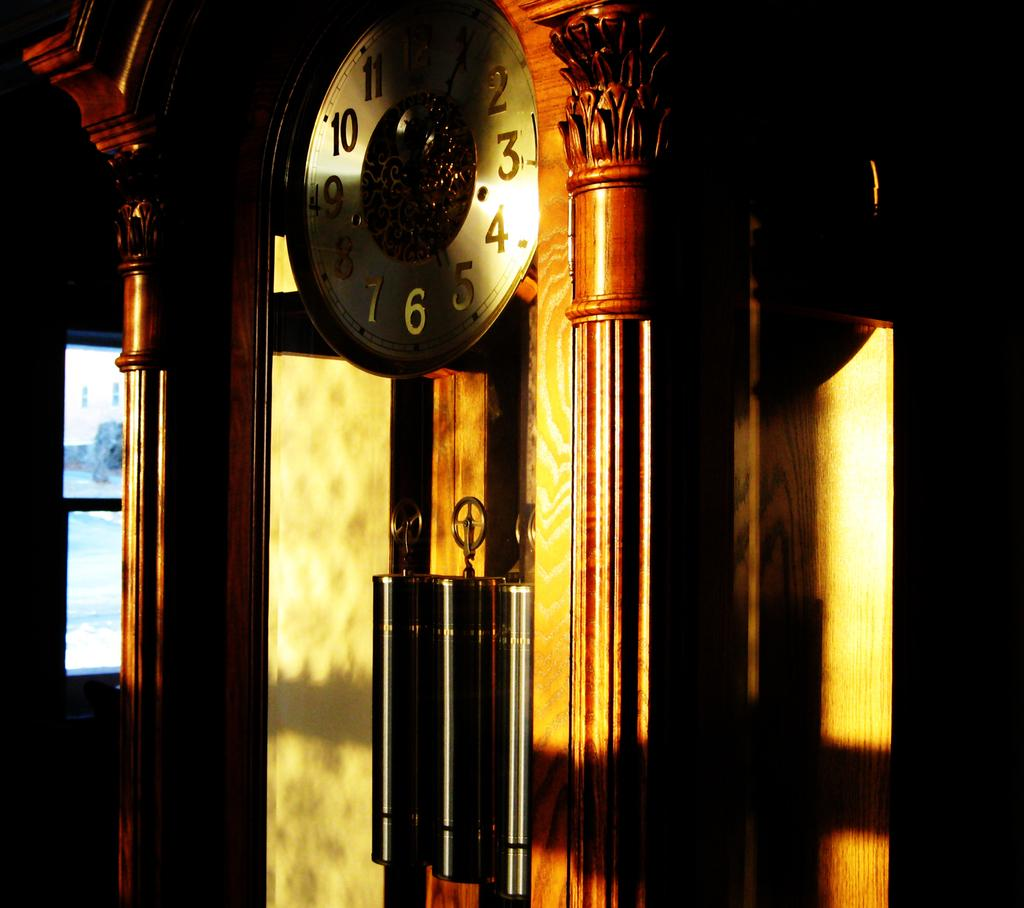<image>
Present a compact description of the photo's key features. On a clock, the numbers 10 and 4 are caught in a bright sunbeam. 